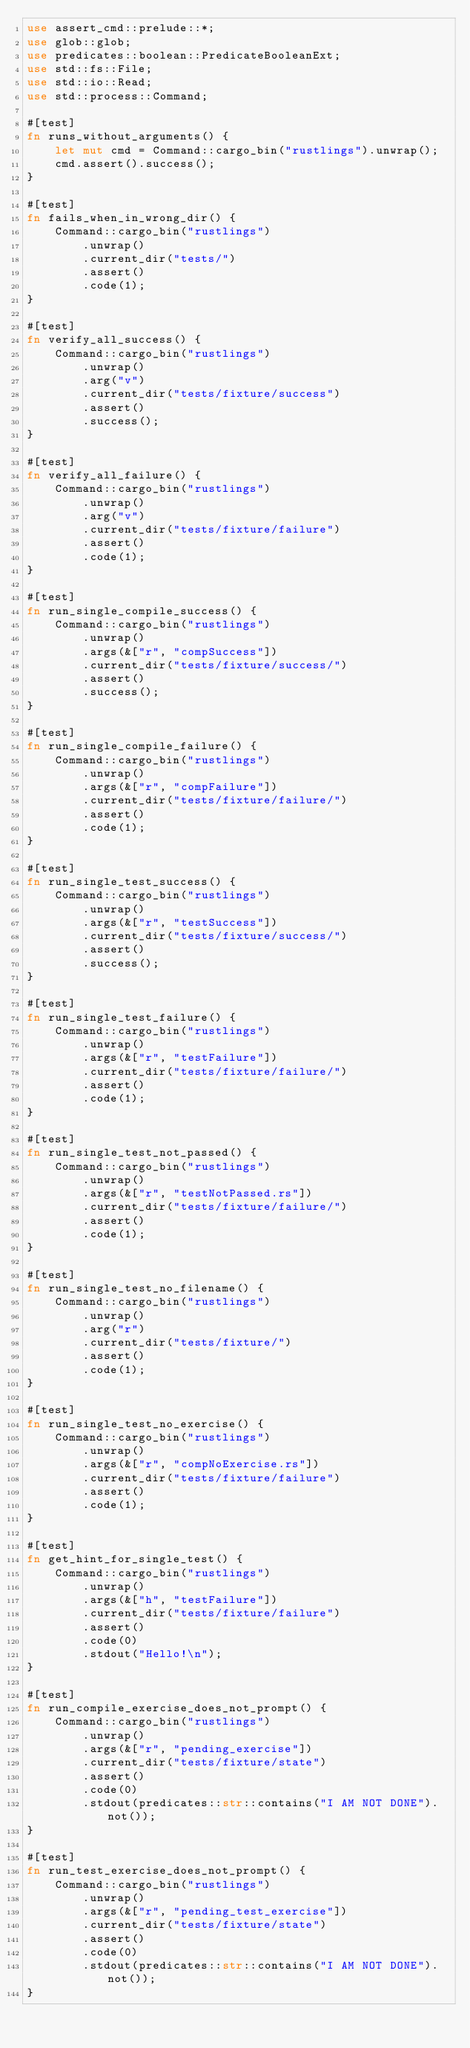Convert code to text. <code><loc_0><loc_0><loc_500><loc_500><_Rust_>use assert_cmd::prelude::*;
use glob::glob;
use predicates::boolean::PredicateBooleanExt;
use std::fs::File;
use std::io::Read;
use std::process::Command;

#[test]
fn runs_without_arguments() {
    let mut cmd = Command::cargo_bin("rustlings").unwrap();
    cmd.assert().success();
}

#[test]
fn fails_when_in_wrong_dir() {
    Command::cargo_bin("rustlings")
        .unwrap()
        .current_dir("tests/")
        .assert()
        .code(1);
}

#[test]
fn verify_all_success() {
    Command::cargo_bin("rustlings")
        .unwrap()
        .arg("v")
        .current_dir("tests/fixture/success")
        .assert()
        .success();
}

#[test]
fn verify_all_failure() {
    Command::cargo_bin("rustlings")
        .unwrap()
        .arg("v")
        .current_dir("tests/fixture/failure")
        .assert()
        .code(1);
}

#[test]
fn run_single_compile_success() {
    Command::cargo_bin("rustlings")
        .unwrap()
        .args(&["r", "compSuccess"])
        .current_dir("tests/fixture/success/")
        .assert()
        .success();
}

#[test]
fn run_single_compile_failure() {
    Command::cargo_bin("rustlings")
        .unwrap()
        .args(&["r", "compFailure"])
        .current_dir("tests/fixture/failure/")
        .assert()
        .code(1);
}

#[test]
fn run_single_test_success() {
    Command::cargo_bin("rustlings")
        .unwrap()
        .args(&["r", "testSuccess"])
        .current_dir("tests/fixture/success/")
        .assert()
        .success();
}

#[test]
fn run_single_test_failure() {
    Command::cargo_bin("rustlings")
        .unwrap()
        .args(&["r", "testFailure"])
        .current_dir("tests/fixture/failure/")
        .assert()
        .code(1);
}

#[test]
fn run_single_test_not_passed() {
    Command::cargo_bin("rustlings")
        .unwrap()
        .args(&["r", "testNotPassed.rs"])
        .current_dir("tests/fixture/failure/")
        .assert()
        .code(1);
}

#[test]
fn run_single_test_no_filename() {
    Command::cargo_bin("rustlings")
        .unwrap()
        .arg("r")
        .current_dir("tests/fixture/")
        .assert()
        .code(1);
}

#[test]
fn run_single_test_no_exercise() {
    Command::cargo_bin("rustlings")
        .unwrap()
        .args(&["r", "compNoExercise.rs"])
        .current_dir("tests/fixture/failure")
        .assert()
        .code(1);
}

#[test]
fn get_hint_for_single_test() {
    Command::cargo_bin("rustlings")
        .unwrap()
        .args(&["h", "testFailure"])
        .current_dir("tests/fixture/failure")
        .assert()
        .code(0)
        .stdout("Hello!\n");
}

#[test]
fn run_compile_exercise_does_not_prompt() {
    Command::cargo_bin("rustlings")
        .unwrap()
        .args(&["r", "pending_exercise"])
        .current_dir("tests/fixture/state")
        .assert()
        .code(0)
        .stdout(predicates::str::contains("I AM NOT DONE").not());
}

#[test]
fn run_test_exercise_does_not_prompt() {
    Command::cargo_bin("rustlings")
        .unwrap()
        .args(&["r", "pending_test_exercise"])
        .current_dir("tests/fixture/state")
        .assert()
        .code(0)
        .stdout(predicates::str::contains("I AM NOT DONE").not());
}
</code> 